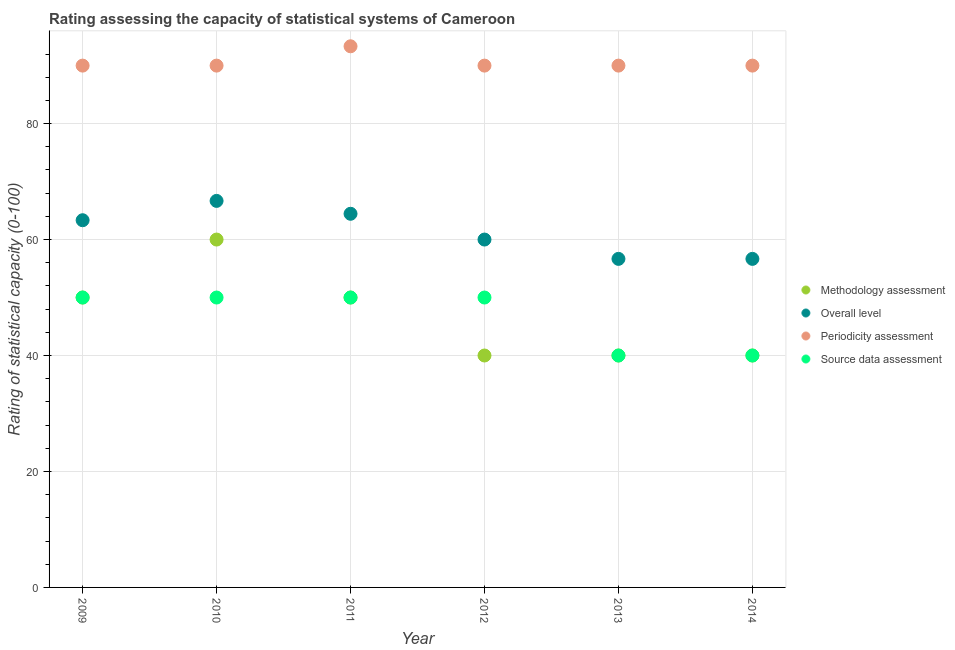How many different coloured dotlines are there?
Provide a succinct answer. 4. Across all years, what is the maximum overall level rating?
Your response must be concise. 66.67. Across all years, what is the minimum overall level rating?
Your answer should be very brief. 56.67. What is the total overall level rating in the graph?
Give a very brief answer. 367.78. What is the difference between the methodology assessment rating in 2010 and that in 2011?
Provide a short and direct response. 10. What is the difference between the source data assessment rating in 2010 and the overall level rating in 2013?
Give a very brief answer. -6.67. What is the average source data assessment rating per year?
Ensure brevity in your answer.  46.67. In the year 2010, what is the difference between the overall level rating and periodicity assessment rating?
Provide a succinct answer. -23.33. Is the periodicity assessment rating in 2010 less than that in 2012?
Your answer should be compact. No. Is the difference between the methodology assessment rating in 2009 and 2011 greater than the difference between the periodicity assessment rating in 2009 and 2011?
Offer a very short reply. Yes. What is the difference between the highest and the second highest periodicity assessment rating?
Give a very brief answer. 3.33. What is the difference between the highest and the lowest periodicity assessment rating?
Your answer should be very brief. 3.33. In how many years, is the periodicity assessment rating greater than the average periodicity assessment rating taken over all years?
Provide a succinct answer. 1. Is it the case that in every year, the sum of the source data assessment rating and overall level rating is greater than the sum of methodology assessment rating and periodicity assessment rating?
Keep it short and to the point. No. Does the methodology assessment rating monotonically increase over the years?
Ensure brevity in your answer.  No. How many years are there in the graph?
Provide a short and direct response. 6. What is the difference between two consecutive major ticks on the Y-axis?
Offer a terse response. 20. Are the values on the major ticks of Y-axis written in scientific E-notation?
Your answer should be compact. No. Does the graph contain any zero values?
Offer a very short reply. No. Does the graph contain grids?
Ensure brevity in your answer.  Yes. Where does the legend appear in the graph?
Provide a short and direct response. Center right. How many legend labels are there?
Your answer should be very brief. 4. What is the title of the graph?
Your answer should be compact. Rating assessing the capacity of statistical systems of Cameroon. What is the label or title of the Y-axis?
Offer a terse response. Rating of statistical capacity (0-100). What is the Rating of statistical capacity (0-100) of Methodology assessment in 2009?
Keep it short and to the point. 50. What is the Rating of statistical capacity (0-100) in Overall level in 2009?
Offer a terse response. 63.33. What is the Rating of statistical capacity (0-100) in Overall level in 2010?
Give a very brief answer. 66.67. What is the Rating of statistical capacity (0-100) in Periodicity assessment in 2010?
Give a very brief answer. 90. What is the Rating of statistical capacity (0-100) of Methodology assessment in 2011?
Make the answer very short. 50. What is the Rating of statistical capacity (0-100) in Overall level in 2011?
Provide a short and direct response. 64.44. What is the Rating of statistical capacity (0-100) of Periodicity assessment in 2011?
Offer a very short reply. 93.33. What is the Rating of statistical capacity (0-100) in Source data assessment in 2011?
Give a very brief answer. 50. What is the Rating of statistical capacity (0-100) of Source data assessment in 2012?
Your response must be concise. 50. What is the Rating of statistical capacity (0-100) of Overall level in 2013?
Keep it short and to the point. 56.67. What is the Rating of statistical capacity (0-100) in Periodicity assessment in 2013?
Offer a very short reply. 90. What is the Rating of statistical capacity (0-100) of Source data assessment in 2013?
Ensure brevity in your answer.  40. What is the Rating of statistical capacity (0-100) in Methodology assessment in 2014?
Your answer should be compact. 40. What is the Rating of statistical capacity (0-100) of Overall level in 2014?
Your answer should be very brief. 56.67. What is the Rating of statistical capacity (0-100) of Periodicity assessment in 2014?
Ensure brevity in your answer.  90. Across all years, what is the maximum Rating of statistical capacity (0-100) of Overall level?
Your answer should be very brief. 66.67. Across all years, what is the maximum Rating of statistical capacity (0-100) in Periodicity assessment?
Give a very brief answer. 93.33. Across all years, what is the maximum Rating of statistical capacity (0-100) in Source data assessment?
Offer a very short reply. 50. Across all years, what is the minimum Rating of statistical capacity (0-100) of Methodology assessment?
Provide a succinct answer. 40. Across all years, what is the minimum Rating of statistical capacity (0-100) of Overall level?
Give a very brief answer. 56.67. Across all years, what is the minimum Rating of statistical capacity (0-100) of Periodicity assessment?
Provide a short and direct response. 90. What is the total Rating of statistical capacity (0-100) of Methodology assessment in the graph?
Keep it short and to the point. 280. What is the total Rating of statistical capacity (0-100) in Overall level in the graph?
Your response must be concise. 367.78. What is the total Rating of statistical capacity (0-100) in Periodicity assessment in the graph?
Provide a succinct answer. 543.33. What is the total Rating of statistical capacity (0-100) of Source data assessment in the graph?
Provide a short and direct response. 280. What is the difference between the Rating of statistical capacity (0-100) of Methodology assessment in 2009 and that in 2010?
Provide a short and direct response. -10. What is the difference between the Rating of statistical capacity (0-100) of Source data assessment in 2009 and that in 2010?
Make the answer very short. 0. What is the difference between the Rating of statistical capacity (0-100) in Methodology assessment in 2009 and that in 2011?
Keep it short and to the point. 0. What is the difference between the Rating of statistical capacity (0-100) of Overall level in 2009 and that in 2011?
Your answer should be compact. -1.11. What is the difference between the Rating of statistical capacity (0-100) of Source data assessment in 2009 and that in 2011?
Give a very brief answer. 0. What is the difference between the Rating of statistical capacity (0-100) in Overall level in 2009 and that in 2012?
Provide a succinct answer. 3.33. What is the difference between the Rating of statistical capacity (0-100) of Periodicity assessment in 2009 and that in 2012?
Your response must be concise. 0. What is the difference between the Rating of statistical capacity (0-100) in Overall level in 2009 and that in 2013?
Provide a short and direct response. 6.67. What is the difference between the Rating of statistical capacity (0-100) of Periodicity assessment in 2009 and that in 2013?
Give a very brief answer. 0. What is the difference between the Rating of statistical capacity (0-100) of Methodology assessment in 2009 and that in 2014?
Your answer should be very brief. 10. What is the difference between the Rating of statistical capacity (0-100) of Overall level in 2009 and that in 2014?
Offer a very short reply. 6.67. What is the difference between the Rating of statistical capacity (0-100) in Methodology assessment in 2010 and that in 2011?
Provide a short and direct response. 10. What is the difference between the Rating of statistical capacity (0-100) in Overall level in 2010 and that in 2011?
Your answer should be compact. 2.22. What is the difference between the Rating of statistical capacity (0-100) of Methodology assessment in 2010 and that in 2012?
Give a very brief answer. 20. What is the difference between the Rating of statistical capacity (0-100) of Overall level in 2010 and that in 2012?
Keep it short and to the point. 6.67. What is the difference between the Rating of statistical capacity (0-100) of Periodicity assessment in 2010 and that in 2012?
Offer a terse response. 0. What is the difference between the Rating of statistical capacity (0-100) of Source data assessment in 2010 and that in 2012?
Keep it short and to the point. 0. What is the difference between the Rating of statistical capacity (0-100) in Methodology assessment in 2010 and that in 2013?
Your answer should be very brief. 20. What is the difference between the Rating of statistical capacity (0-100) in Source data assessment in 2010 and that in 2013?
Provide a succinct answer. 10. What is the difference between the Rating of statistical capacity (0-100) in Methodology assessment in 2010 and that in 2014?
Give a very brief answer. 20. What is the difference between the Rating of statistical capacity (0-100) in Overall level in 2010 and that in 2014?
Provide a short and direct response. 10. What is the difference between the Rating of statistical capacity (0-100) of Periodicity assessment in 2010 and that in 2014?
Your response must be concise. 0. What is the difference between the Rating of statistical capacity (0-100) of Methodology assessment in 2011 and that in 2012?
Your response must be concise. 10. What is the difference between the Rating of statistical capacity (0-100) of Overall level in 2011 and that in 2012?
Offer a terse response. 4.44. What is the difference between the Rating of statistical capacity (0-100) in Periodicity assessment in 2011 and that in 2012?
Ensure brevity in your answer.  3.33. What is the difference between the Rating of statistical capacity (0-100) in Source data assessment in 2011 and that in 2012?
Make the answer very short. 0. What is the difference between the Rating of statistical capacity (0-100) of Overall level in 2011 and that in 2013?
Provide a succinct answer. 7.78. What is the difference between the Rating of statistical capacity (0-100) in Periodicity assessment in 2011 and that in 2013?
Offer a terse response. 3.33. What is the difference between the Rating of statistical capacity (0-100) of Overall level in 2011 and that in 2014?
Provide a short and direct response. 7.78. What is the difference between the Rating of statistical capacity (0-100) of Periodicity assessment in 2011 and that in 2014?
Your response must be concise. 3.33. What is the difference between the Rating of statistical capacity (0-100) of Source data assessment in 2011 and that in 2014?
Provide a succinct answer. 10. What is the difference between the Rating of statistical capacity (0-100) in Methodology assessment in 2012 and that in 2013?
Ensure brevity in your answer.  0. What is the difference between the Rating of statistical capacity (0-100) in Periodicity assessment in 2012 and that in 2013?
Keep it short and to the point. 0. What is the difference between the Rating of statistical capacity (0-100) of Source data assessment in 2012 and that in 2013?
Your answer should be compact. 10. What is the difference between the Rating of statistical capacity (0-100) of Periodicity assessment in 2012 and that in 2014?
Give a very brief answer. 0. What is the difference between the Rating of statistical capacity (0-100) in Source data assessment in 2012 and that in 2014?
Your response must be concise. 10. What is the difference between the Rating of statistical capacity (0-100) in Methodology assessment in 2013 and that in 2014?
Make the answer very short. 0. What is the difference between the Rating of statistical capacity (0-100) in Overall level in 2013 and that in 2014?
Make the answer very short. 0. What is the difference between the Rating of statistical capacity (0-100) of Periodicity assessment in 2013 and that in 2014?
Provide a short and direct response. 0. What is the difference between the Rating of statistical capacity (0-100) in Methodology assessment in 2009 and the Rating of statistical capacity (0-100) in Overall level in 2010?
Your answer should be very brief. -16.67. What is the difference between the Rating of statistical capacity (0-100) of Methodology assessment in 2009 and the Rating of statistical capacity (0-100) of Periodicity assessment in 2010?
Ensure brevity in your answer.  -40. What is the difference between the Rating of statistical capacity (0-100) of Methodology assessment in 2009 and the Rating of statistical capacity (0-100) of Source data assessment in 2010?
Your response must be concise. 0. What is the difference between the Rating of statistical capacity (0-100) in Overall level in 2009 and the Rating of statistical capacity (0-100) in Periodicity assessment in 2010?
Offer a very short reply. -26.67. What is the difference between the Rating of statistical capacity (0-100) in Overall level in 2009 and the Rating of statistical capacity (0-100) in Source data assessment in 2010?
Provide a succinct answer. 13.33. What is the difference between the Rating of statistical capacity (0-100) in Periodicity assessment in 2009 and the Rating of statistical capacity (0-100) in Source data assessment in 2010?
Make the answer very short. 40. What is the difference between the Rating of statistical capacity (0-100) of Methodology assessment in 2009 and the Rating of statistical capacity (0-100) of Overall level in 2011?
Make the answer very short. -14.44. What is the difference between the Rating of statistical capacity (0-100) in Methodology assessment in 2009 and the Rating of statistical capacity (0-100) in Periodicity assessment in 2011?
Make the answer very short. -43.33. What is the difference between the Rating of statistical capacity (0-100) in Overall level in 2009 and the Rating of statistical capacity (0-100) in Periodicity assessment in 2011?
Give a very brief answer. -30. What is the difference between the Rating of statistical capacity (0-100) of Overall level in 2009 and the Rating of statistical capacity (0-100) of Source data assessment in 2011?
Give a very brief answer. 13.33. What is the difference between the Rating of statistical capacity (0-100) of Methodology assessment in 2009 and the Rating of statistical capacity (0-100) of Periodicity assessment in 2012?
Provide a succinct answer. -40. What is the difference between the Rating of statistical capacity (0-100) in Methodology assessment in 2009 and the Rating of statistical capacity (0-100) in Source data assessment in 2012?
Your answer should be very brief. 0. What is the difference between the Rating of statistical capacity (0-100) of Overall level in 2009 and the Rating of statistical capacity (0-100) of Periodicity assessment in 2012?
Offer a terse response. -26.67. What is the difference between the Rating of statistical capacity (0-100) in Overall level in 2009 and the Rating of statistical capacity (0-100) in Source data assessment in 2012?
Make the answer very short. 13.33. What is the difference between the Rating of statistical capacity (0-100) of Periodicity assessment in 2009 and the Rating of statistical capacity (0-100) of Source data assessment in 2012?
Provide a succinct answer. 40. What is the difference between the Rating of statistical capacity (0-100) in Methodology assessment in 2009 and the Rating of statistical capacity (0-100) in Overall level in 2013?
Provide a short and direct response. -6.67. What is the difference between the Rating of statistical capacity (0-100) of Methodology assessment in 2009 and the Rating of statistical capacity (0-100) of Periodicity assessment in 2013?
Your answer should be very brief. -40. What is the difference between the Rating of statistical capacity (0-100) in Overall level in 2009 and the Rating of statistical capacity (0-100) in Periodicity assessment in 2013?
Offer a very short reply. -26.67. What is the difference between the Rating of statistical capacity (0-100) of Overall level in 2009 and the Rating of statistical capacity (0-100) of Source data assessment in 2013?
Provide a short and direct response. 23.33. What is the difference between the Rating of statistical capacity (0-100) in Methodology assessment in 2009 and the Rating of statistical capacity (0-100) in Overall level in 2014?
Offer a terse response. -6.67. What is the difference between the Rating of statistical capacity (0-100) in Overall level in 2009 and the Rating of statistical capacity (0-100) in Periodicity assessment in 2014?
Make the answer very short. -26.67. What is the difference between the Rating of statistical capacity (0-100) of Overall level in 2009 and the Rating of statistical capacity (0-100) of Source data assessment in 2014?
Offer a terse response. 23.33. What is the difference between the Rating of statistical capacity (0-100) in Periodicity assessment in 2009 and the Rating of statistical capacity (0-100) in Source data assessment in 2014?
Your response must be concise. 50. What is the difference between the Rating of statistical capacity (0-100) of Methodology assessment in 2010 and the Rating of statistical capacity (0-100) of Overall level in 2011?
Make the answer very short. -4.44. What is the difference between the Rating of statistical capacity (0-100) of Methodology assessment in 2010 and the Rating of statistical capacity (0-100) of Periodicity assessment in 2011?
Offer a very short reply. -33.33. What is the difference between the Rating of statistical capacity (0-100) of Overall level in 2010 and the Rating of statistical capacity (0-100) of Periodicity assessment in 2011?
Provide a succinct answer. -26.67. What is the difference between the Rating of statistical capacity (0-100) of Overall level in 2010 and the Rating of statistical capacity (0-100) of Source data assessment in 2011?
Ensure brevity in your answer.  16.67. What is the difference between the Rating of statistical capacity (0-100) of Methodology assessment in 2010 and the Rating of statistical capacity (0-100) of Overall level in 2012?
Make the answer very short. 0. What is the difference between the Rating of statistical capacity (0-100) in Overall level in 2010 and the Rating of statistical capacity (0-100) in Periodicity assessment in 2012?
Provide a succinct answer. -23.33. What is the difference between the Rating of statistical capacity (0-100) of Overall level in 2010 and the Rating of statistical capacity (0-100) of Source data assessment in 2012?
Provide a succinct answer. 16.67. What is the difference between the Rating of statistical capacity (0-100) of Methodology assessment in 2010 and the Rating of statistical capacity (0-100) of Overall level in 2013?
Ensure brevity in your answer.  3.33. What is the difference between the Rating of statistical capacity (0-100) in Methodology assessment in 2010 and the Rating of statistical capacity (0-100) in Periodicity assessment in 2013?
Your response must be concise. -30. What is the difference between the Rating of statistical capacity (0-100) of Methodology assessment in 2010 and the Rating of statistical capacity (0-100) of Source data assessment in 2013?
Give a very brief answer. 20. What is the difference between the Rating of statistical capacity (0-100) in Overall level in 2010 and the Rating of statistical capacity (0-100) in Periodicity assessment in 2013?
Your answer should be compact. -23.33. What is the difference between the Rating of statistical capacity (0-100) of Overall level in 2010 and the Rating of statistical capacity (0-100) of Source data assessment in 2013?
Give a very brief answer. 26.67. What is the difference between the Rating of statistical capacity (0-100) in Periodicity assessment in 2010 and the Rating of statistical capacity (0-100) in Source data assessment in 2013?
Your answer should be compact. 50. What is the difference between the Rating of statistical capacity (0-100) in Methodology assessment in 2010 and the Rating of statistical capacity (0-100) in Source data assessment in 2014?
Give a very brief answer. 20. What is the difference between the Rating of statistical capacity (0-100) in Overall level in 2010 and the Rating of statistical capacity (0-100) in Periodicity assessment in 2014?
Ensure brevity in your answer.  -23.33. What is the difference between the Rating of statistical capacity (0-100) in Overall level in 2010 and the Rating of statistical capacity (0-100) in Source data assessment in 2014?
Give a very brief answer. 26.67. What is the difference between the Rating of statistical capacity (0-100) of Overall level in 2011 and the Rating of statistical capacity (0-100) of Periodicity assessment in 2012?
Provide a succinct answer. -25.56. What is the difference between the Rating of statistical capacity (0-100) of Overall level in 2011 and the Rating of statistical capacity (0-100) of Source data assessment in 2012?
Your answer should be very brief. 14.44. What is the difference between the Rating of statistical capacity (0-100) in Periodicity assessment in 2011 and the Rating of statistical capacity (0-100) in Source data assessment in 2012?
Keep it short and to the point. 43.33. What is the difference between the Rating of statistical capacity (0-100) of Methodology assessment in 2011 and the Rating of statistical capacity (0-100) of Overall level in 2013?
Keep it short and to the point. -6.67. What is the difference between the Rating of statistical capacity (0-100) of Methodology assessment in 2011 and the Rating of statistical capacity (0-100) of Source data assessment in 2013?
Give a very brief answer. 10. What is the difference between the Rating of statistical capacity (0-100) of Overall level in 2011 and the Rating of statistical capacity (0-100) of Periodicity assessment in 2013?
Keep it short and to the point. -25.56. What is the difference between the Rating of statistical capacity (0-100) of Overall level in 2011 and the Rating of statistical capacity (0-100) of Source data assessment in 2013?
Your answer should be very brief. 24.44. What is the difference between the Rating of statistical capacity (0-100) of Periodicity assessment in 2011 and the Rating of statistical capacity (0-100) of Source data assessment in 2013?
Make the answer very short. 53.33. What is the difference between the Rating of statistical capacity (0-100) in Methodology assessment in 2011 and the Rating of statistical capacity (0-100) in Overall level in 2014?
Make the answer very short. -6.67. What is the difference between the Rating of statistical capacity (0-100) in Methodology assessment in 2011 and the Rating of statistical capacity (0-100) in Source data assessment in 2014?
Provide a succinct answer. 10. What is the difference between the Rating of statistical capacity (0-100) of Overall level in 2011 and the Rating of statistical capacity (0-100) of Periodicity assessment in 2014?
Your answer should be compact. -25.56. What is the difference between the Rating of statistical capacity (0-100) of Overall level in 2011 and the Rating of statistical capacity (0-100) of Source data assessment in 2014?
Make the answer very short. 24.44. What is the difference between the Rating of statistical capacity (0-100) in Periodicity assessment in 2011 and the Rating of statistical capacity (0-100) in Source data assessment in 2014?
Your answer should be compact. 53.33. What is the difference between the Rating of statistical capacity (0-100) in Methodology assessment in 2012 and the Rating of statistical capacity (0-100) in Overall level in 2013?
Provide a succinct answer. -16.67. What is the difference between the Rating of statistical capacity (0-100) of Methodology assessment in 2012 and the Rating of statistical capacity (0-100) of Periodicity assessment in 2013?
Your response must be concise. -50. What is the difference between the Rating of statistical capacity (0-100) in Overall level in 2012 and the Rating of statistical capacity (0-100) in Periodicity assessment in 2013?
Offer a terse response. -30. What is the difference between the Rating of statistical capacity (0-100) of Periodicity assessment in 2012 and the Rating of statistical capacity (0-100) of Source data assessment in 2013?
Offer a terse response. 50. What is the difference between the Rating of statistical capacity (0-100) in Methodology assessment in 2012 and the Rating of statistical capacity (0-100) in Overall level in 2014?
Offer a terse response. -16.67. What is the difference between the Rating of statistical capacity (0-100) in Methodology assessment in 2012 and the Rating of statistical capacity (0-100) in Periodicity assessment in 2014?
Provide a short and direct response. -50. What is the difference between the Rating of statistical capacity (0-100) of Methodology assessment in 2012 and the Rating of statistical capacity (0-100) of Source data assessment in 2014?
Keep it short and to the point. 0. What is the difference between the Rating of statistical capacity (0-100) in Periodicity assessment in 2012 and the Rating of statistical capacity (0-100) in Source data assessment in 2014?
Ensure brevity in your answer.  50. What is the difference between the Rating of statistical capacity (0-100) of Methodology assessment in 2013 and the Rating of statistical capacity (0-100) of Overall level in 2014?
Ensure brevity in your answer.  -16.67. What is the difference between the Rating of statistical capacity (0-100) in Methodology assessment in 2013 and the Rating of statistical capacity (0-100) in Periodicity assessment in 2014?
Your answer should be compact. -50. What is the difference between the Rating of statistical capacity (0-100) of Overall level in 2013 and the Rating of statistical capacity (0-100) of Periodicity assessment in 2014?
Your response must be concise. -33.33. What is the difference between the Rating of statistical capacity (0-100) of Overall level in 2013 and the Rating of statistical capacity (0-100) of Source data assessment in 2014?
Ensure brevity in your answer.  16.67. What is the difference between the Rating of statistical capacity (0-100) in Periodicity assessment in 2013 and the Rating of statistical capacity (0-100) in Source data assessment in 2014?
Offer a very short reply. 50. What is the average Rating of statistical capacity (0-100) of Methodology assessment per year?
Provide a succinct answer. 46.67. What is the average Rating of statistical capacity (0-100) of Overall level per year?
Your response must be concise. 61.3. What is the average Rating of statistical capacity (0-100) of Periodicity assessment per year?
Provide a short and direct response. 90.56. What is the average Rating of statistical capacity (0-100) in Source data assessment per year?
Your answer should be compact. 46.67. In the year 2009, what is the difference between the Rating of statistical capacity (0-100) in Methodology assessment and Rating of statistical capacity (0-100) in Overall level?
Provide a succinct answer. -13.33. In the year 2009, what is the difference between the Rating of statistical capacity (0-100) in Methodology assessment and Rating of statistical capacity (0-100) in Periodicity assessment?
Provide a succinct answer. -40. In the year 2009, what is the difference between the Rating of statistical capacity (0-100) in Overall level and Rating of statistical capacity (0-100) in Periodicity assessment?
Offer a very short reply. -26.67. In the year 2009, what is the difference between the Rating of statistical capacity (0-100) in Overall level and Rating of statistical capacity (0-100) in Source data assessment?
Offer a terse response. 13.33. In the year 2010, what is the difference between the Rating of statistical capacity (0-100) in Methodology assessment and Rating of statistical capacity (0-100) in Overall level?
Your response must be concise. -6.67. In the year 2010, what is the difference between the Rating of statistical capacity (0-100) in Overall level and Rating of statistical capacity (0-100) in Periodicity assessment?
Keep it short and to the point. -23.33. In the year 2010, what is the difference between the Rating of statistical capacity (0-100) of Overall level and Rating of statistical capacity (0-100) of Source data assessment?
Your answer should be compact. 16.67. In the year 2010, what is the difference between the Rating of statistical capacity (0-100) in Periodicity assessment and Rating of statistical capacity (0-100) in Source data assessment?
Keep it short and to the point. 40. In the year 2011, what is the difference between the Rating of statistical capacity (0-100) of Methodology assessment and Rating of statistical capacity (0-100) of Overall level?
Keep it short and to the point. -14.44. In the year 2011, what is the difference between the Rating of statistical capacity (0-100) in Methodology assessment and Rating of statistical capacity (0-100) in Periodicity assessment?
Give a very brief answer. -43.33. In the year 2011, what is the difference between the Rating of statistical capacity (0-100) in Methodology assessment and Rating of statistical capacity (0-100) in Source data assessment?
Offer a very short reply. 0. In the year 2011, what is the difference between the Rating of statistical capacity (0-100) in Overall level and Rating of statistical capacity (0-100) in Periodicity assessment?
Your answer should be very brief. -28.89. In the year 2011, what is the difference between the Rating of statistical capacity (0-100) in Overall level and Rating of statistical capacity (0-100) in Source data assessment?
Offer a very short reply. 14.44. In the year 2011, what is the difference between the Rating of statistical capacity (0-100) of Periodicity assessment and Rating of statistical capacity (0-100) of Source data assessment?
Offer a very short reply. 43.33. In the year 2012, what is the difference between the Rating of statistical capacity (0-100) of Methodology assessment and Rating of statistical capacity (0-100) of Overall level?
Make the answer very short. -20. In the year 2012, what is the difference between the Rating of statistical capacity (0-100) of Methodology assessment and Rating of statistical capacity (0-100) of Source data assessment?
Keep it short and to the point. -10. In the year 2012, what is the difference between the Rating of statistical capacity (0-100) of Overall level and Rating of statistical capacity (0-100) of Periodicity assessment?
Make the answer very short. -30. In the year 2012, what is the difference between the Rating of statistical capacity (0-100) of Periodicity assessment and Rating of statistical capacity (0-100) of Source data assessment?
Make the answer very short. 40. In the year 2013, what is the difference between the Rating of statistical capacity (0-100) of Methodology assessment and Rating of statistical capacity (0-100) of Overall level?
Provide a succinct answer. -16.67. In the year 2013, what is the difference between the Rating of statistical capacity (0-100) of Methodology assessment and Rating of statistical capacity (0-100) of Periodicity assessment?
Ensure brevity in your answer.  -50. In the year 2013, what is the difference between the Rating of statistical capacity (0-100) of Methodology assessment and Rating of statistical capacity (0-100) of Source data assessment?
Provide a succinct answer. 0. In the year 2013, what is the difference between the Rating of statistical capacity (0-100) of Overall level and Rating of statistical capacity (0-100) of Periodicity assessment?
Provide a succinct answer. -33.33. In the year 2013, what is the difference between the Rating of statistical capacity (0-100) of Overall level and Rating of statistical capacity (0-100) of Source data assessment?
Your response must be concise. 16.67. In the year 2013, what is the difference between the Rating of statistical capacity (0-100) in Periodicity assessment and Rating of statistical capacity (0-100) in Source data assessment?
Offer a terse response. 50. In the year 2014, what is the difference between the Rating of statistical capacity (0-100) of Methodology assessment and Rating of statistical capacity (0-100) of Overall level?
Ensure brevity in your answer.  -16.67. In the year 2014, what is the difference between the Rating of statistical capacity (0-100) of Overall level and Rating of statistical capacity (0-100) of Periodicity assessment?
Your answer should be very brief. -33.33. In the year 2014, what is the difference between the Rating of statistical capacity (0-100) of Overall level and Rating of statistical capacity (0-100) of Source data assessment?
Give a very brief answer. 16.67. What is the ratio of the Rating of statistical capacity (0-100) of Overall level in 2009 to that in 2010?
Give a very brief answer. 0.95. What is the ratio of the Rating of statistical capacity (0-100) in Periodicity assessment in 2009 to that in 2010?
Give a very brief answer. 1. What is the ratio of the Rating of statistical capacity (0-100) of Source data assessment in 2009 to that in 2010?
Provide a short and direct response. 1. What is the ratio of the Rating of statistical capacity (0-100) in Methodology assessment in 2009 to that in 2011?
Provide a succinct answer. 1. What is the ratio of the Rating of statistical capacity (0-100) in Overall level in 2009 to that in 2011?
Your answer should be compact. 0.98. What is the ratio of the Rating of statistical capacity (0-100) of Periodicity assessment in 2009 to that in 2011?
Keep it short and to the point. 0.96. What is the ratio of the Rating of statistical capacity (0-100) of Source data assessment in 2009 to that in 2011?
Your answer should be very brief. 1. What is the ratio of the Rating of statistical capacity (0-100) of Methodology assessment in 2009 to that in 2012?
Your answer should be compact. 1.25. What is the ratio of the Rating of statistical capacity (0-100) in Overall level in 2009 to that in 2012?
Provide a succinct answer. 1.06. What is the ratio of the Rating of statistical capacity (0-100) in Source data assessment in 2009 to that in 2012?
Make the answer very short. 1. What is the ratio of the Rating of statistical capacity (0-100) in Methodology assessment in 2009 to that in 2013?
Offer a terse response. 1.25. What is the ratio of the Rating of statistical capacity (0-100) in Overall level in 2009 to that in 2013?
Offer a very short reply. 1.12. What is the ratio of the Rating of statistical capacity (0-100) of Periodicity assessment in 2009 to that in 2013?
Your response must be concise. 1. What is the ratio of the Rating of statistical capacity (0-100) in Source data assessment in 2009 to that in 2013?
Your answer should be very brief. 1.25. What is the ratio of the Rating of statistical capacity (0-100) in Overall level in 2009 to that in 2014?
Your response must be concise. 1.12. What is the ratio of the Rating of statistical capacity (0-100) in Methodology assessment in 2010 to that in 2011?
Your response must be concise. 1.2. What is the ratio of the Rating of statistical capacity (0-100) of Overall level in 2010 to that in 2011?
Your answer should be compact. 1.03. What is the ratio of the Rating of statistical capacity (0-100) of Methodology assessment in 2010 to that in 2012?
Your answer should be very brief. 1.5. What is the ratio of the Rating of statistical capacity (0-100) of Periodicity assessment in 2010 to that in 2012?
Keep it short and to the point. 1. What is the ratio of the Rating of statistical capacity (0-100) in Source data assessment in 2010 to that in 2012?
Provide a short and direct response. 1. What is the ratio of the Rating of statistical capacity (0-100) in Overall level in 2010 to that in 2013?
Your answer should be compact. 1.18. What is the ratio of the Rating of statistical capacity (0-100) in Source data assessment in 2010 to that in 2013?
Your answer should be compact. 1.25. What is the ratio of the Rating of statistical capacity (0-100) in Overall level in 2010 to that in 2014?
Provide a succinct answer. 1.18. What is the ratio of the Rating of statistical capacity (0-100) of Overall level in 2011 to that in 2012?
Your response must be concise. 1.07. What is the ratio of the Rating of statistical capacity (0-100) of Source data assessment in 2011 to that in 2012?
Give a very brief answer. 1. What is the ratio of the Rating of statistical capacity (0-100) of Methodology assessment in 2011 to that in 2013?
Offer a terse response. 1.25. What is the ratio of the Rating of statistical capacity (0-100) in Overall level in 2011 to that in 2013?
Provide a short and direct response. 1.14. What is the ratio of the Rating of statistical capacity (0-100) in Source data assessment in 2011 to that in 2013?
Your answer should be compact. 1.25. What is the ratio of the Rating of statistical capacity (0-100) of Overall level in 2011 to that in 2014?
Offer a very short reply. 1.14. What is the ratio of the Rating of statistical capacity (0-100) of Methodology assessment in 2012 to that in 2013?
Offer a terse response. 1. What is the ratio of the Rating of statistical capacity (0-100) in Overall level in 2012 to that in 2013?
Your answer should be very brief. 1.06. What is the ratio of the Rating of statistical capacity (0-100) in Source data assessment in 2012 to that in 2013?
Your answer should be very brief. 1.25. What is the ratio of the Rating of statistical capacity (0-100) of Methodology assessment in 2012 to that in 2014?
Your answer should be very brief. 1. What is the ratio of the Rating of statistical capacity (0-100) of Overall level in 2012 to that in 2014?
Your response must be concise. 1.06. What is the ratio of the Rating of statistical capacity (0-100) of Source data assessment in 2012 to that in 2014?
Make the answer very short. 1.25. What is the ratio of the Rating of statistical capacity (0-100) in Overall level in 2013 to that in 2014?
Offer a very short reply. 1. What is the difference between the highest and the second highest Rating of statistical capacity (0-100) in Methodology assessment?
Your answer should be very brief. 10. What is the difference between the highest and the second highest Rating of statistical capacity (0-100) of Overall level?
Offer a very short reply. 2.22. What is the difference between the highest and the second highest Rating of statistical capacity (0-100) in Periodicity assessment?
Provide a short and direct response. 3.33. What is the difference between the highest and the lowest Rating of statistical capacity (0-100) of Overall level?
Offer a terse response. 10. 